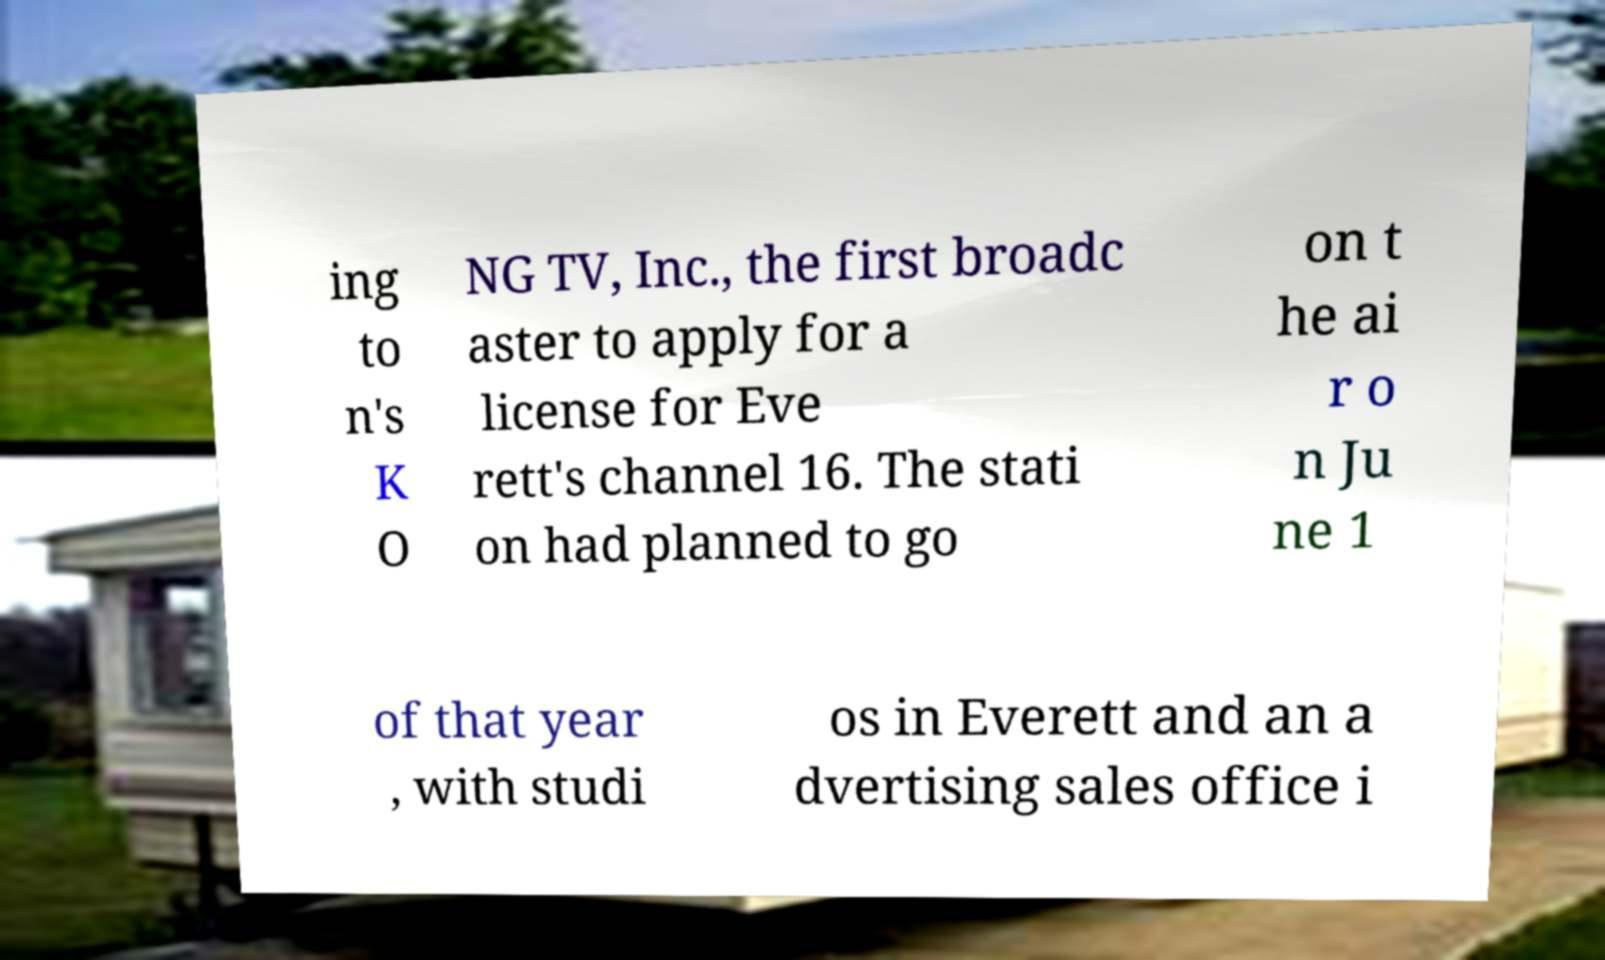Can you read and provide the text displayed in the image?This photo seems to have some interesting text. Can you extract and type it out for me? ing to n's K O NG TV, Inc., the first broadc aster to apply for a license for Eve rett's channel 16. The stati on had planned to go on t he ai r o n Ju ne 1 of that year , with studi os in Everett and an a dvertising sales office i 